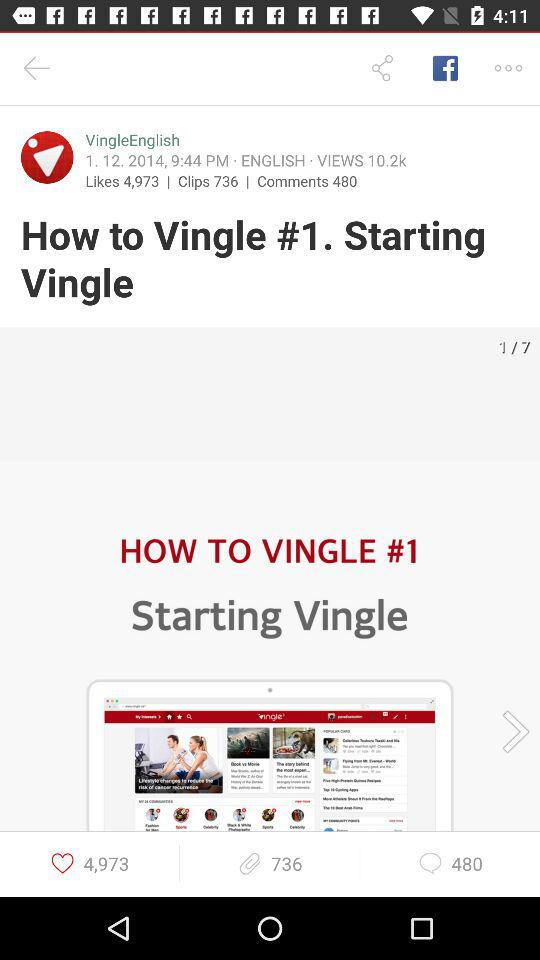How many more likes does the video have than clips?
Answer the question using a single word or phrase. 4237 